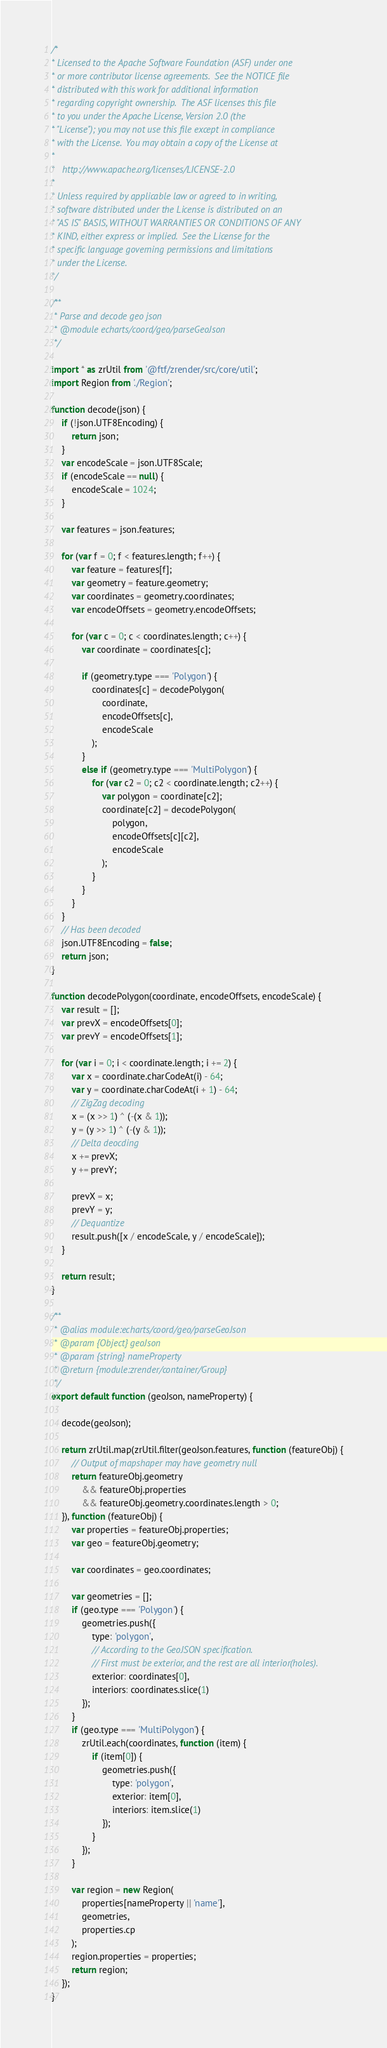<code> <loc_0><loc_0><loc_500><loc_500><_JavaScript_>/*
* Licensed to the Apache Software Foundation (ASF) under one
* or more contributor license agreements.  See the NOTICE file
* distributed with this work for additional information
* regarding copyright ownership.  The ASF licenses this file
* to you under the Apache License, Version 2.0 (the
* "License"); you may not use this file except in compliance
* with the License.  You may obtain a copy of the License at
*
*   http://www.apache.org/licenses/LICENSE-2.0
*
* Unless required by applicable law or agreed to in writing,
* software distributed under the License is distributed on an
* "AS IS" BASIS, WITHOUT WARRANTIES OR CONDITIONS OF ANY
* KIND, either express or implied.  See the License for the
* specific language governing permissions and limitations
* under the License.
*/

/**
 * Parse and decode geo json
 * @module echarts/coord/geo/parseGeoJson
 */

import * as zrUtil from '@ftf/zrender/src/core/util';
import Region from './Region';

function decode(json) {
    if (!json.UTF8Encoding) {
        return json;
    }
    var encodeScale = json.UTF8Scale;
    if (encodeScale == null) {
        encodeScale = 1024;
    }

    var features = json.features;

    for (var f = 0; f < features.length; f++) {
        var feature = features[f];
        var geometry = feature.geometry;
        var coordinates = geometry.coordinates;
        var encodeOffsets = geometry.encodeOffsets;

        for (var c = 0; c < coordinates.length; c++) {
            var coordinate = coordinates[c];

            if (geometry.type === 'Polygon') {
                coordinates[c] = decodePolygon(
                    coordinate,
                    encodeOffsets[c],
                    encodeScale
                );
            }
            else if (geometry.type === 'MultiPolygon') {
                for (var c2 = 0; c2 < coordinate.length; c2++) {
                    var polygon = coordinate[c2];
                    coordinate[c2] = decodePolygon(
                        polygon,
                        encodeOffsets[c][c2],
                        encodeScale
                    );
                }
            }
        }
    }
    // Has been decoded
    json.UTF8Encoding = false;
    return json;
}

function decodePolygon(coordinate, encodeOffsets, encodeScale) {
    var result = [];
    var prevX = encodeOffsets[0];
    var prevY = encodeOffsets[1];

    for (var i = 0; i < coordinate.length; i += 2) {
        var x = coordinate.charCodeAt(i) - 64;
        var y = coordinate.charCodeAt(i + 1) - 64;
        // ZigZag decoding
        x = (x >> 1) ^ (-(x & 1));
        y = (y >> 1) ^ (-(y & 1));
        // Delta deocding
        x += prevX;
        y += prevY;

        prevX = x;
        prevY = y;
        // Dequantize
        result.push([x / encodeScale, y / encodeScale]);
    }

    return result;
}

/**
 * @alias module:echarts/coord/geo/parseGeoJson
 * @param {Object} geoJson
 * @param {string} nameProperty
 * @return {module:zrender/container/Group}
 */
export default function (geoJson, nameProperty) {

    decode(geoJson);

    return zrUtil.map(zrUtil.filter(geoJson.features, function (featureObj) {
        // Output of mapshaper may have geometry null
        return featureObj.geometry
            && featureObj.properties
            && featureObj.geometry.coordinates.length > 0;
    }), function (featureObj) {
        var properties = featureObj.properties;
        var geo = featureObj.geometry;

        var coordinates = geo.coordinates;

        var geometries = [];
        if (geo.type === 'Polygon') {
            geometries.push({
                type: 'polygon',
                // According to the GeoJSON specification.
                // First must be exterior, and the rest are all interior(holes).
                exterior: coordinates[0],
                interiors: coordinates.slice(1)
            });
        }
        if (geo.type === 'MultiPolygon') {
            zrUtil.each(coordinates, function (item) {
                if (item[0]) {
                    geometries.push({
                        type: 'polygon',
                        exterior: item[0],
                        interiors: item.slice(1)
                    });
                }
            });
        }

        var region = new Region(
            properties[nameProperty || 'name'],
            geometries,
            properties.cp
        );
        region.properties = properties;
        return region;
    });
}</code> 